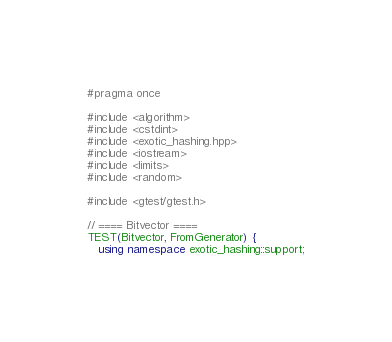Convert code to text. <code><loc_0><loc_0><loc_500><loc_500><_C++_>#pragma once

#include <algorithm>
#include <cstdint>
#include <exotic_hashing.hpp>
#include <iostream>
#include <limits>
#include <random>

#include <gtest/gtest.h>

// ==== Bitvector ====
TEST(Bitvector, FromGenerator) {
   using namespace exotic_hashing::support;
</code> 